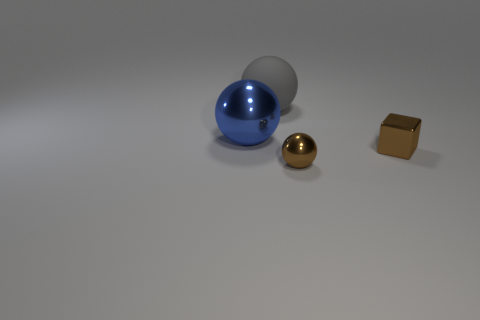What material is the tiny object on the left side of the tiny brown thing on the right side of the shiny sphere to the right of the blue sphere?
Offer a terse response. Metal. Are the tiny brown sphere and the ball that is on the left side of the rubber ball made of the same material?
Offer a terse response. Yes. What is the material of the gray thing that is the same shape as the blue metal object?
Keep it short and to the point. Rubber. Is there anything else that is the same material as the gray object?
Give a very brief answer. No. Is the number of small blocks in front of the big rubber sphere greater than the number of brown shiny objects that are behind the big blue shiny ball?
Give a very brief answer. Yes. The brown object that is the same material as the tiny ball is what shape?
Make the answer very short. Cube. What number of other objects are the same shape as the blue thing?
Offer a terse response. 2. There is a small thing behind the tiny metal ball; what shape is it?
Your response must be concise. Cube. What color is the shiny block?
Your answer should be very brief. Brown. What number of other things are there of the same size as the brown metal block?
Your response must be concise. 1. 